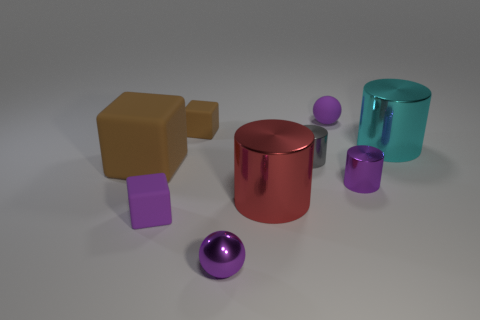There is a purple cube that is the same material as the large brown cube; what size is it?
Give a very brief answer. Small. How many cylinders are tiny objects or big red objects?
Your response must be concise. 3. Are there more cyan shiny objects than red metal blocks?
Your answer should be very brief. Yes. What number of purple blocks are the same size as the purple metallic cylinder?
Offer a terse response. 1. There is a rubber object that is the same color as the small rubber ball; what shape is it?
Ensure brevity in your answer.  Cube. How many objects are either large metal objects that are right of the purple shiny sphere or small gray things?
Give a very brief answer. 3. Is the number of purple metal spheres less than the number of large cylinders?
Offer a very short reply. Yes. There is a large thing that is the same material as the small purple block; what is its shape?
Provide a succinct answer. Cube. Are there any large red metal cylinders on the right side of the purple rubber ball?
Provide a short and direct response. No. Are there fewer gray shiny objects that are in front of the big block than small brown rubber objects?
Ensure brevity in your answer.  Yes. 